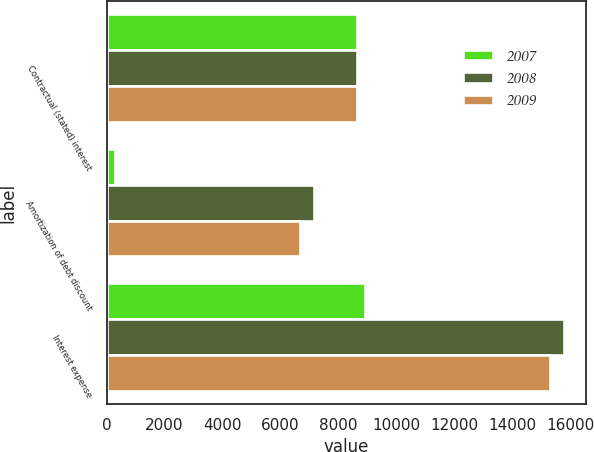Convert chart to OTSL. <chart><loc_0><loc_0><loc_500><loc_500><stacked_bar_chart><ecel><fcel>Contractual (stated) interest<fcel>Amortization of debt discount<fcel>Interest expense<nl><fcel>2007<fcel>8625<fcel>301<fcel>8926<nl><fcel>2008<fcel>8625<fcel>7139<fcel>15764<nl><fcel>2009<fcel>8625<fcel>6660<fcel>15285<nl></chart> 